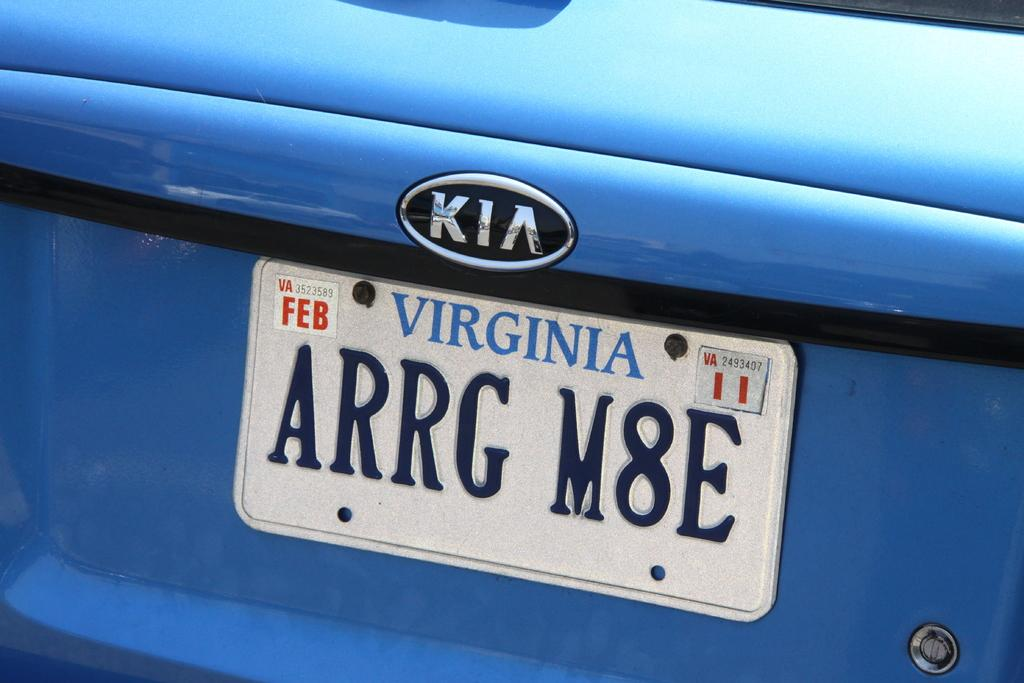<image>
Provide a brief description of the given image. a Virginia sign that is on the back of a car 